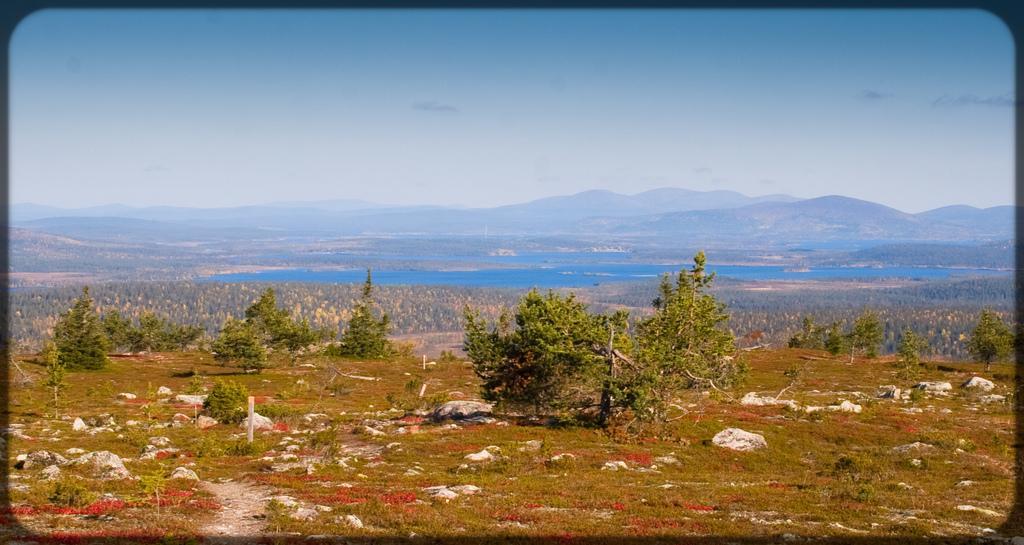Could you give a brief overview of what you see in this image? In this image we can see trees, rocks, poles, grass and other objects. In the background of the image there are mountains, water, trees and other objects. At the top of the image there is the sky. At the bottom of the image there are grass, plants and ground. 